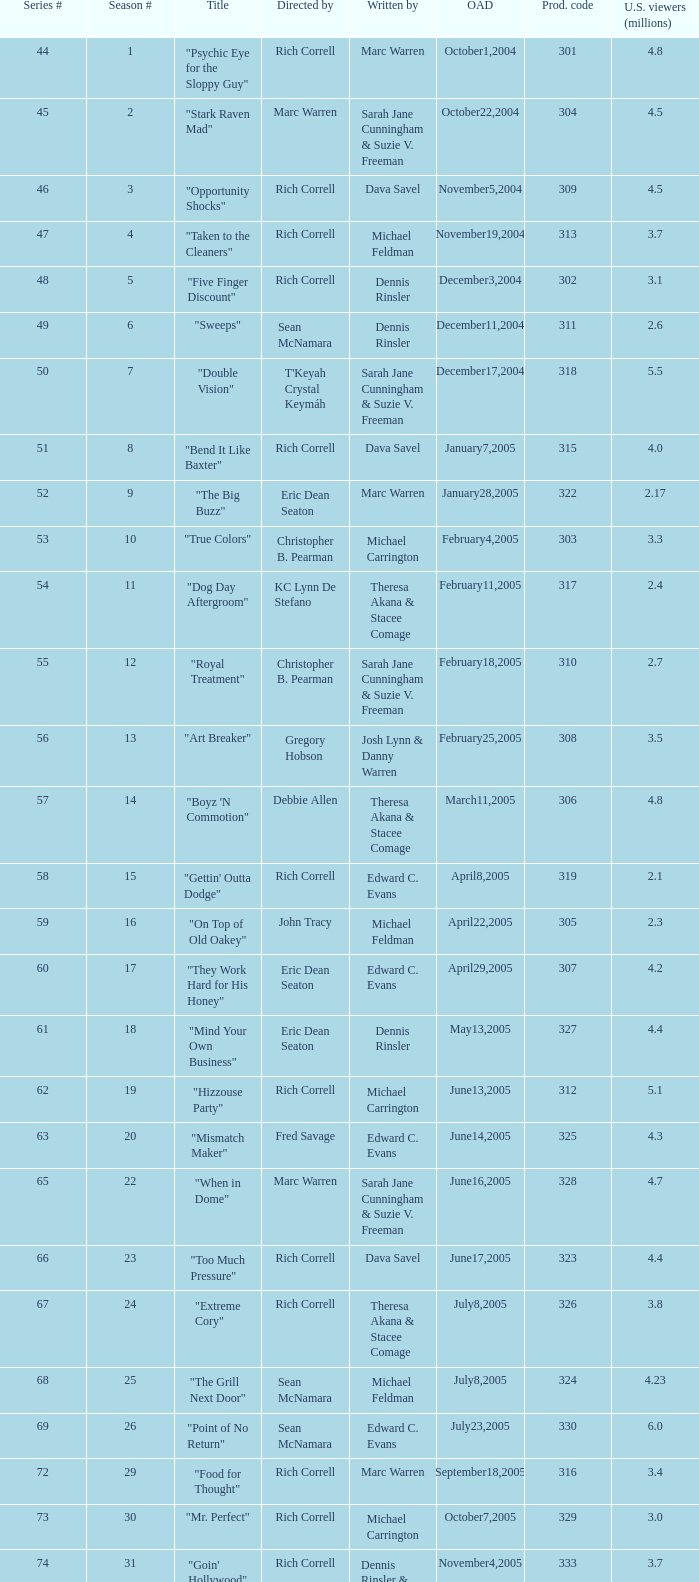What number episode of the season was titled "Vision Impossible"? 34.0. Help me parse the entirety of this table. {'header': ['Series #', 'Season #', 'Title', 'Directed by', 'Written by', 'OAD', 'Prod. code', 'U.S. viewers (millions)'], 'rows': [['44', '1', '"Psychic Eye for the Sloppy Guy"', 'Rich Correll', 'Marc Warren', 'October1,2004', '301', '4.8'], ['45', '2', '"Stark Raven Mad"', 'Marc Warren', 'Sarah Jane Cunningham & Suzie V. Freeman', 'October22,2004', '304', '4.5'], ['46', '3', '"Opportunity Shocks"', 'Rich Correll', 'Dava Savel', 'November5,2004', '309', '4.5'], ['47', '4', '"Taken to the Cleaners"', 'Rich Correll', 'Michael Feldman', 'November19,2004', '313', '3.7'], ['48', '5', '"Five Finger Discount"', 'Rich Correll', 'Dennis Rinsler', 'December3,2004', '302', '3.1'], ['49', '6', '"Sweeps"', 'Sean McNamara', 'Dennis Rinsler', 'December11,2004', '311', '2.6'], ['50', '7', '"Double Vision"', "T'Keyah Crystal Keymáh", 'Sarah Jane Cunningham & Suzie V. Freeman', 'December17,2004', '318', '5.5'], ['51', '8', '"Bend It Like Baxter"', 'Rich Correll', 'Dava Savel', 'January7,2005', '315', '4.0'], ['52', '9', '"The Big Buzz"', 'Eric Dean Seaton', 'Marc Warren', 'January28,2005', '322', '2.17'], ['53', '10', '"True Colors"', 'Christopher B. Pearman', 'Michael Carrington', 'February4,2005', '303', '3.3'], ['54', '11', '"Dog Day Aftergroom"', 'KC Lynn De Stefano', 'Theresa Akana & Stacee Comage', 'February11,2005', '317', '2.4'], ['55', '12', '"Royal Treatment"', 'Christopher B. Pearman', 'Sarah Jane Cunningham & Suzie V. Freeman', 'February18,2005', '310', '2.7'], ['56', '13', '"Art Breaker"', 'Gregory Hobson', 'Josh Lynn & Danny Warren', 'February25,2005', '308', '3.5'], ['57', '14', '"Boyz \'N Commotion"', 'Debbie Allen', 'Theresa Akana & Stacee Comage', 'March11,2005', '306', '4.8'], ['58', '15', '"Gettin\' Outta Dodge"', 'Rich Correll', 'Edward C. Evans', 'April8,2005', '319', '2.1'], ['59', '16', '"On Top of Old Oakey"', 'John Tracy', 'Michael Feldman', 'April22,2005', '305', '2.3'], ['60', '17', '"They Work Hard for His Honey"', 'Eric Dean Seaton', 'Edward C. Evans', 'April29,2005', '307', '4.2'], ['61', '18', '"Mind Your Own Business"', 'Eric Dean Seaton', 'Dennis Rinsler', 'May13,2005', '327', '4.4'], ['62', '19', '"Hizzouse Party"', 'Rich Correll', 'Michael Carrington', 'June13,2005', '312', '5.1'], ['63', '20', '"Mismatch Maker"', 'Fred Savage', 'Edward C. Evans', 'June14,2005', '325', '4.3'], ['65', '22', '"When in Dome"', 'Marc Warren', 'Sarah Jane Cunningham & Suzie V. Freeman', 'June16,2005', '328', '4.7'], ['66', '23', '"Too Much Pressure"', 'Rich Correll', 'Dava Savel', 'June17,2005', '323', '4.4'], ['67', '24', '"Extreme Cory"', 'Rich Correll', 'Theresa Akana & Stacee Comage', 'July8,2005', '326', '3.8'], ['68', '25', '"The Grill Next Door"', 'Sean McNamara', 'Michael Feldman', 'July8,2005', '324', '4.23'], ['69', '26', '"Point of No Return"', 'Sean McNamara', 'Edward C. Evans', 'July23,2005', '330', '6.0'], ['72', '29', '"Food for Thought"', 'Rich Correll', 'Marc Warren', 'September18,2005', '316', '3.4'], ['73', '30', '"Mr. Perfect"', 'Rich Correll', 'Michael Carrington', 'October7,2005', '329', '3.0'], ['74', '31', '"Goin\' Hollywood"', 'Rich Correll', 'Dennis Rinsler & Marc Warren', 'November4,2005', '333', '3.7'], ['75', '32', '"Save the Last Dance"', 'Sean McNamara', 'Marc Warren', 'November25,2005', '334', '3.3'], ['76', '33', '"Cake Fear"', 'Rondell Sheridan', 'Theresa Akana & Stacee Comage', 'December16,2005', '332', '3.6'], ['77', '34', '"Vision Impossible"', 'Marc Warren', 'David Brookwell & Sean McNamara', 'January6,2006', '335', '4.7']]} 